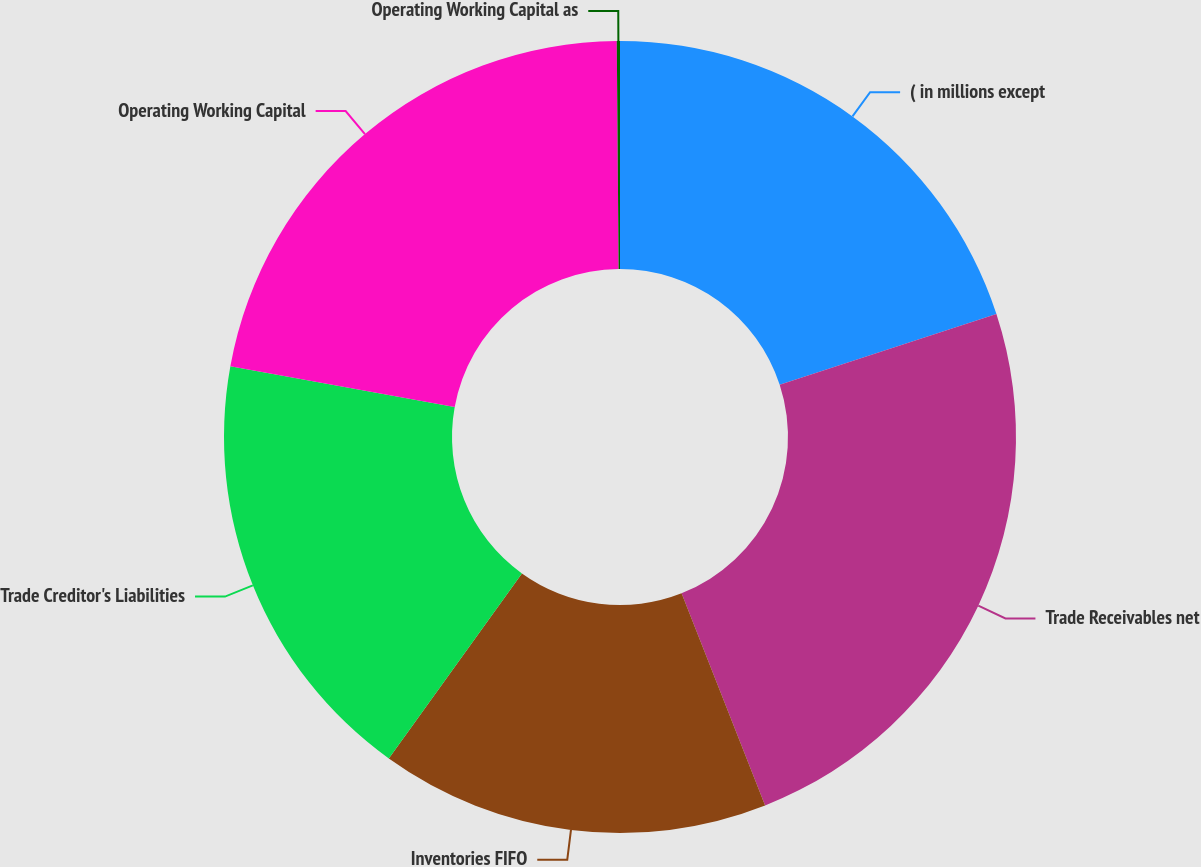Convert chart to OTSL. <chart><loc_0><loc_0><loc_500><loc_500><pie_chart><fcel>( in millions except<fcel>Trade Receivables net<fcel>Inventories FIFO<fcel>Trade Creditor's Liabilities<fcel>Operating Working Capital<fcel>Operating Working Capital as<nl><fcel>19.97%<fcel>24.05%<fcel>15.89%<fcel>17.93%<fcel>22.01%<fcel>0.13%<nl></chart> 